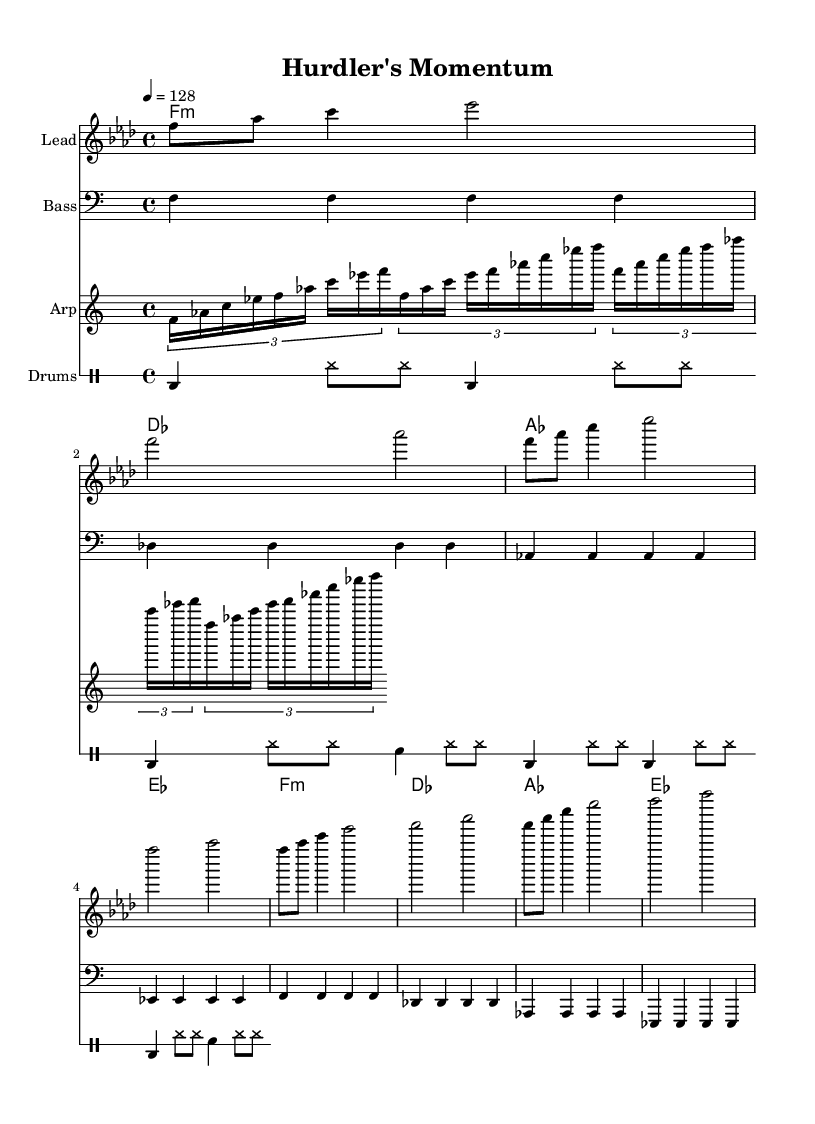What is the key signature of this music? The key signature is indicated by the sharps or flats at the beginning of the music. Here, it shows four flats, which defines the key of F minor.
Answer: F minor What is the time signature of this music? The time signature is located near the beginning of the music and indicates how many beats are in each measure and what kind of note gets a beat. The indicated time signature is 4/4, meaning there are four beats per measure and a quarter note gets one beat.
Answer: 4/4 What is the tempo marking in the sheet music? The tempo marking appears at the beginning of the score and indicates the speed of the music. Here, it is marked as "4 = 128," which means there are 128 beats per minute.
Answer: 128 How many measures does the melody contain? To determine the number of measures in the melody, one must count the bar lines present in the melody section. In this case, there are 8 measures, as each line represents a separate measure.
Answer: 8 What is the main genre of this music piece? The style or genre is often indicated within the title or context of the piece. The title "Hurdler's Momentum" and the use of long builds suggests that this piece is designed for a training or endurance setting, characteristic of Progressive House music.
Answer: Progressive House What is the bassline rhythm pattern in the piece? The bassline is a distinct component of the music, often appearing in steady beats. In this case, the bassline is consistent across the measures, playing on the quarter notes, which aids in creating a solid groove typical of house music. The predominant rhythm follows a steady quarter-note pattern.
Answer: Quarter notes What is the function of the arpeggiator in this music? The arpeggiator plays a sequence of notes broken into individual pitches, creating a sweeping or flowing sound. In this piece, it adds texture and reinforces the harmony by playing arpeggiated figures that fit within the chord structure, typical in progressive house to build tension over time.
Answer: Texture enhancement 